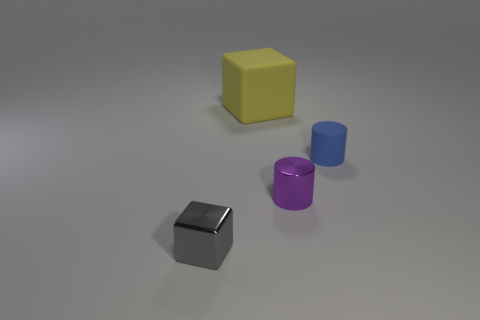There is a yellow object that is the same shape as the small gray shiny thing; what is its material?
Ensure brevity in your answer.  Rubber. Are any big yellow metal things visible?
Provide a short and direct response. No. Are there any blue cylinders that have the same material as the big yellow block?
Offer a terse response. Yes. The large object is what color?
Offer a terse response. Yellow. The rubber cylinder that is the same size as the gray shiny object is what color?
Give a very brief answer. Blue. How many metal things are purple cylinders or tiny cylinders?
Make the answer very short. 1. What number of things are left of the small purple metallic thing and behind the metallic cylinder?
Keep it short and to the point. 1. Is there any other thing that has the same shape as the big yellow thing?
Provide a short and direct response. Yes. What number of other objects are the same size as the purple metal cylinder?
Make the answer very short. 2. There is a thing on the left side of the yellow rubber object; is its size the same as the block behind the small blue matte thing?
Make the answer very short. No. 